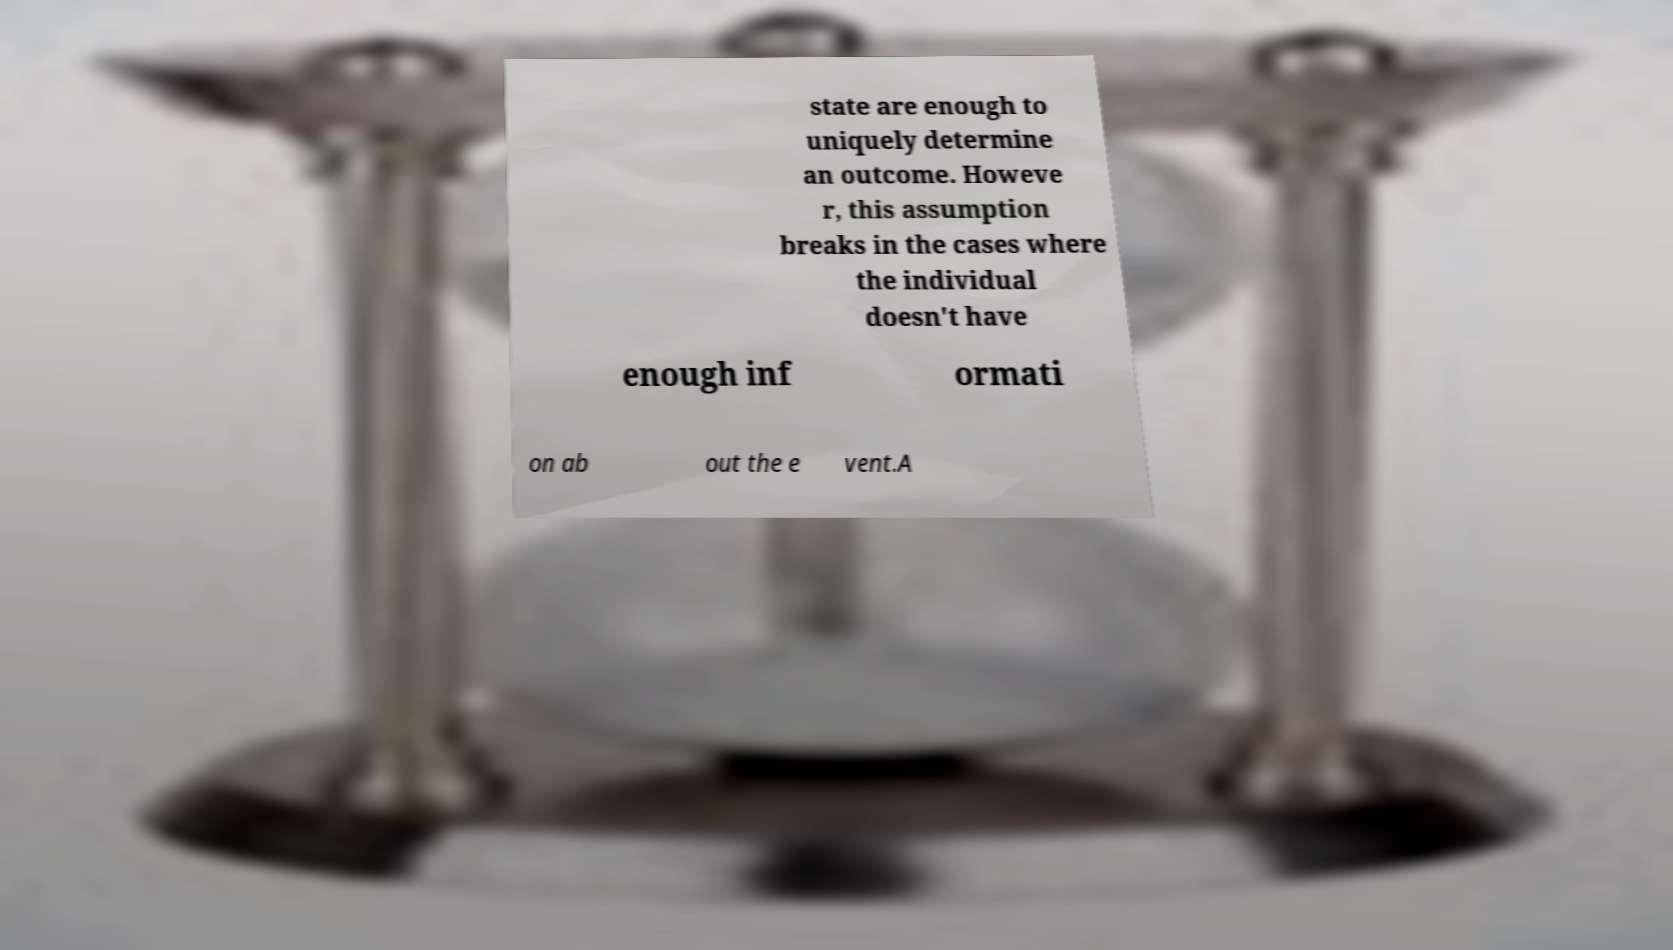Can you read and provide the text displayed in the image?This photo seems to have some interesting text. Can you extract and type it out for me? state are enough to uniquely determine an outcome. Howeve r, this assumption breaks in the cases where the individual doesn't have enough inf ormati on ab out the e vent.A 